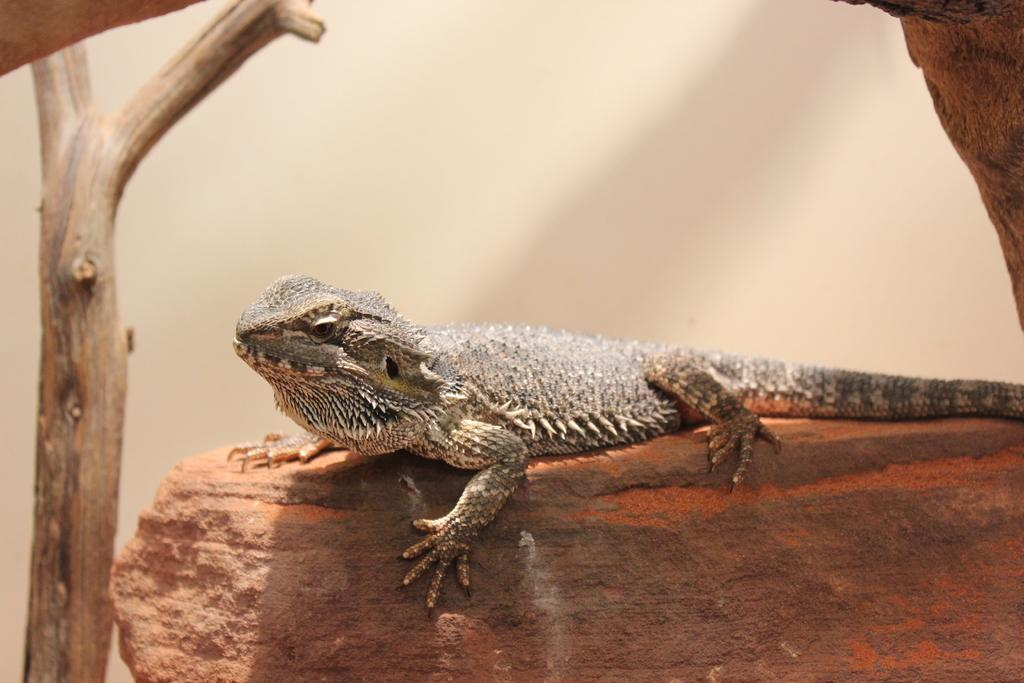What type of animal is in the image? There is a brown chameleon in the image. What is the chameleon sitting on? The chameleon is sitting on a stone. What other object can be seen in the image? There is a wooden stick in the image. What color is the background of the image? The background of the image is white. What type of net is being used to catch the chameleon in the image? There is no net present in the image, and the chameleon is not being caught. 